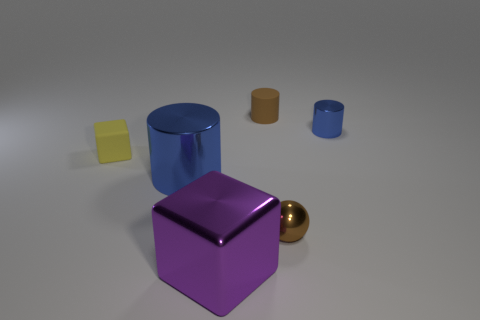Add 4 blue shiny objects. How many objects exist? 10 Subtract all cubes. How many objects are left? 4 Subtract all brown matte cylinders. Subtract all gray rubber balls. How many objects are left? 5 Add 5 purple metal blocks. How many purple metal blocks are left? 6 Add 3 small gray rubber balls. How many small gray rubber balls exist? 3 Subtract 1 brown spheres. How many objects are left? 5 